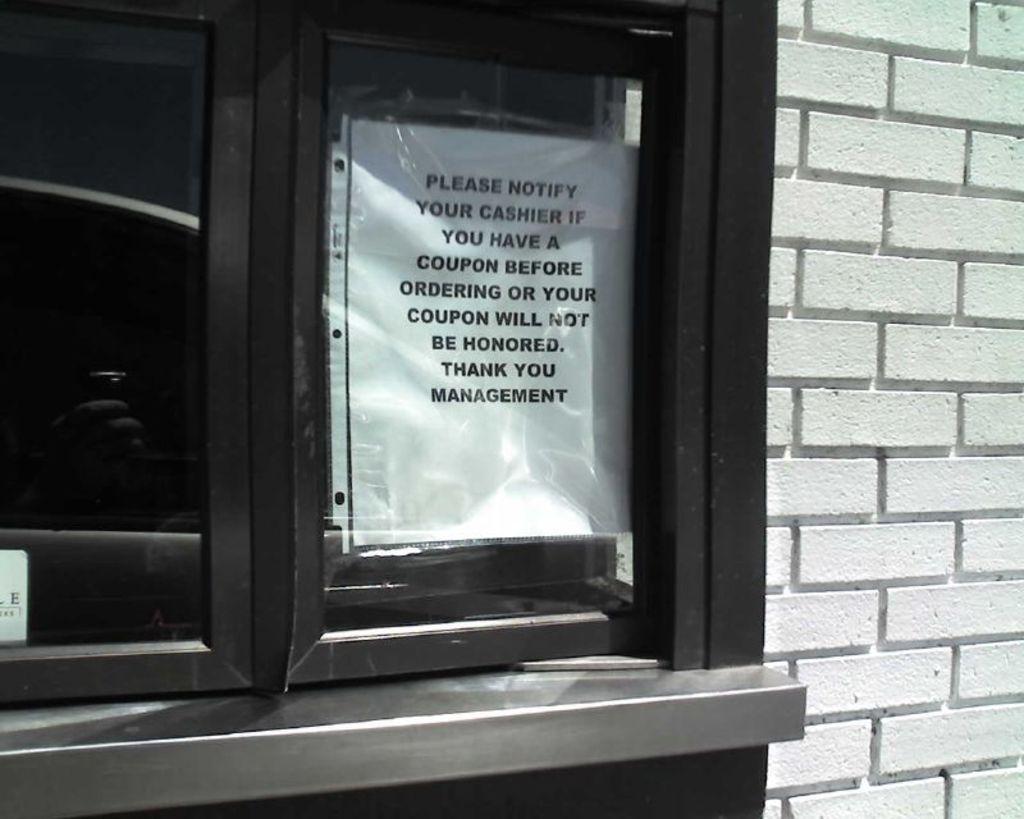Who does the sign say you should notify?
Your answer should be compact. Cashier. 